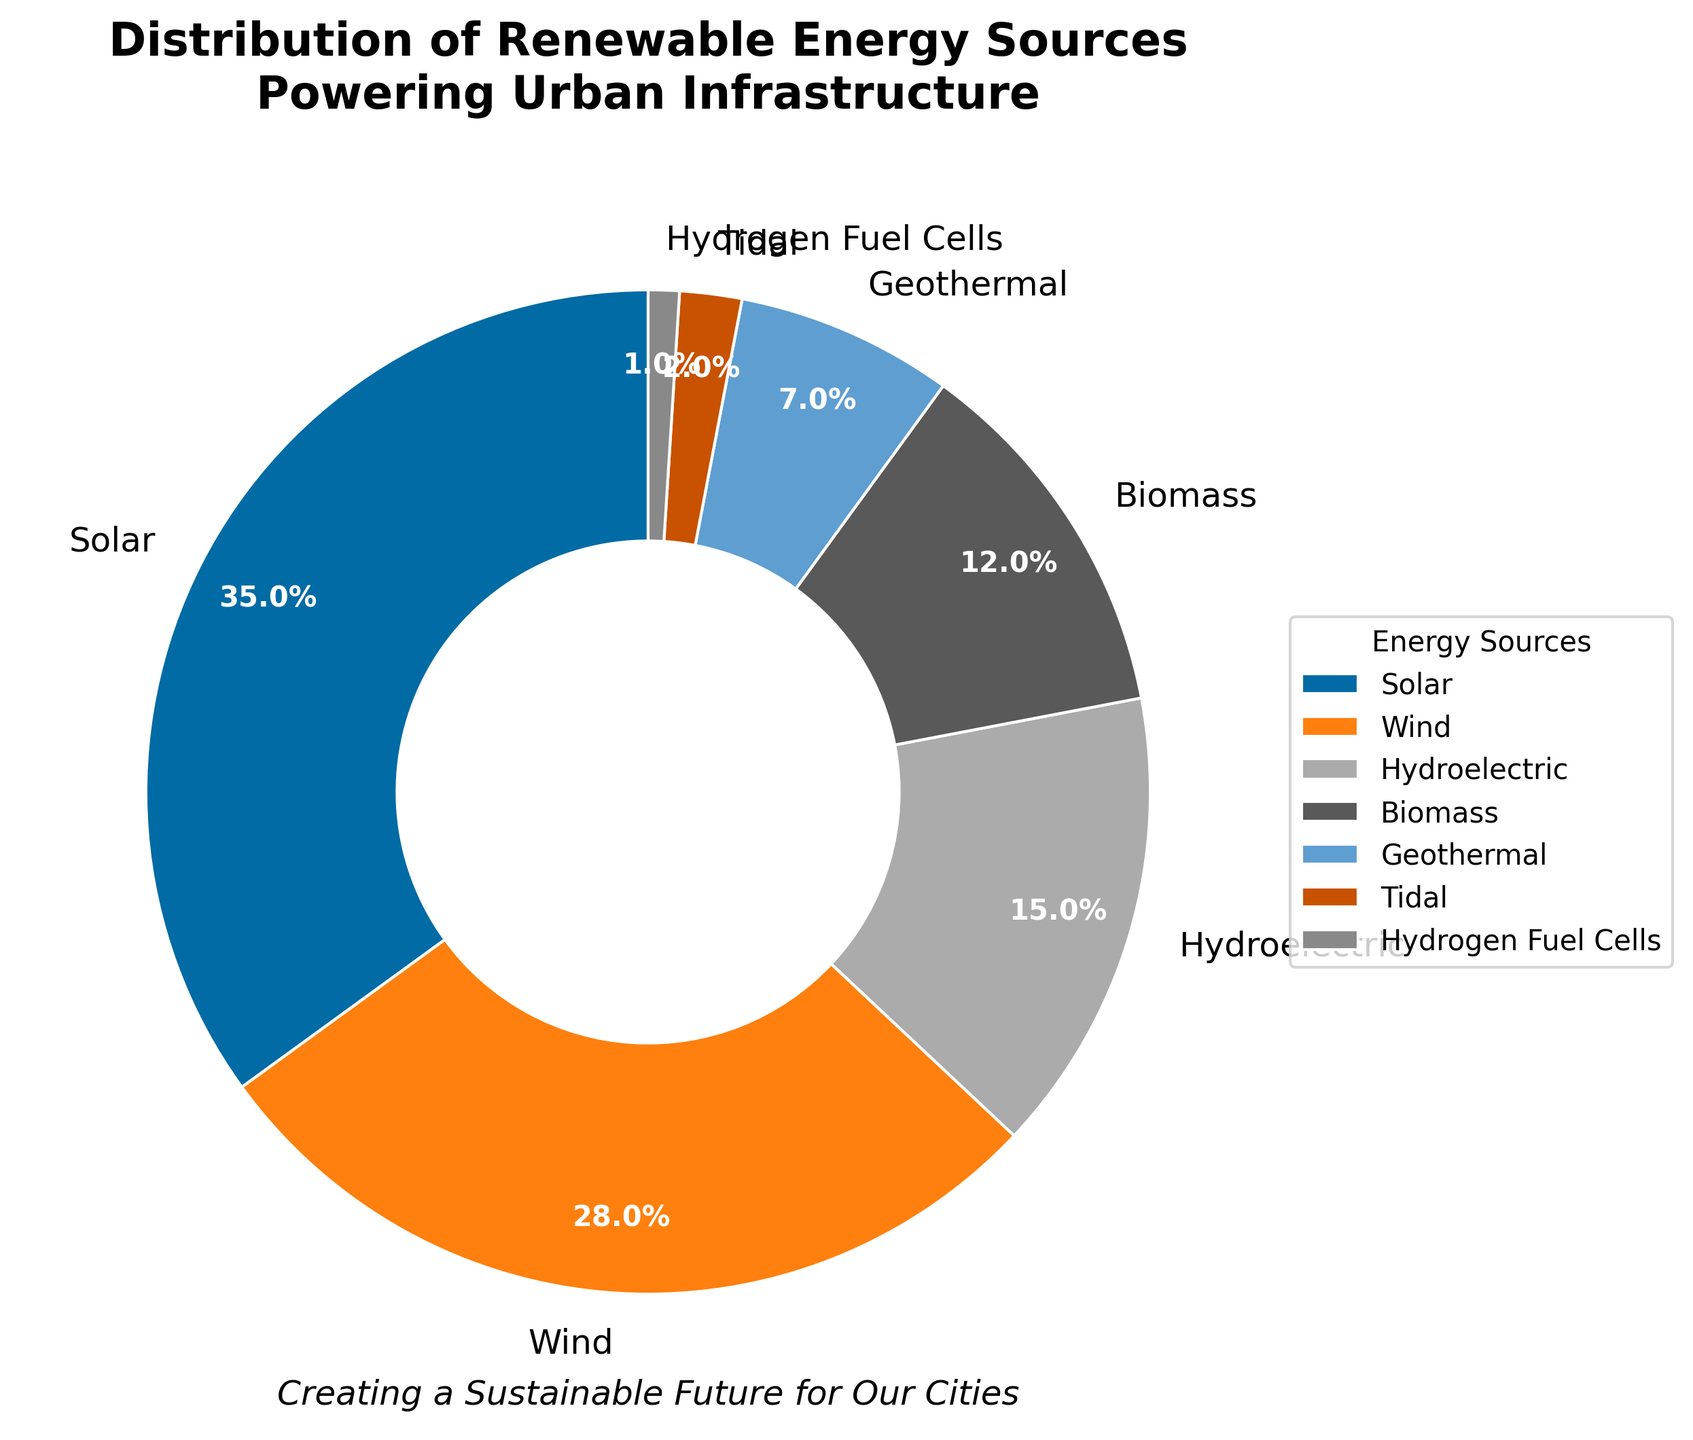What's the most used renewable energy source powering urban infrastructure? By looking at the pie chart, the segment labeled with the highest percentage represents the most used energy source. The largest segment is labeled "Solar" with 35%.
Answer: Solar Which renewable energy source has the smallest share? The smallest segment in the pie chart represents the least used energy source. The segment labeled "Hydrogen Fuel Cells" with 1% is the smallest.
Answer: Hydrogen Fuel Cells What is the combined percentage of Biomass and Geothermal energy sources? To find the combined percentage, sum the percentages of Biomass and Geothermal. Biomass is 12% and Geothermal is 7%, thus 12% + 7% = 19%.
Answer: 19% Which energy source contributes more, Wind or Hydroelectric? Compare the percentages of Wind and Hydroelectric on the pie chart. Wind contributes 28%, and Hydroelectric contributes 15%. Since 28% is greater than 15%, Wind contributes more.
Answer: Wind How much greater is the percentage of Solar compared to Tidal? Subtract the percentage of Tidal from the percentage of Solar. Solar is 35%, and Tidal is 2%, so 35% - 2% = 33%.
Answer: 33% What is the difference in percentage between Wind and Biomass? Subtract the percentage of Biomass from the percentage of Wind. Wind is 28%, and Biomass is 12%, so 28% - 12% = 16%.
Answer: 16% What percentage of renewable energy sources other than Solar power urban infrastructure? Subtract the percentage of Solar from 100% to find the combined percentage of all other sources. 100% - 35% = 65%.
Answer: 65% Which energy source is more prevalent, Geothermal or Tidal? Compare the percentages of Geothermal and Tidal. Geothermal is 7%, and Tidal is 2%. Since 7% is greater than 2%, Geothermal is more prevalent.
Answer: Geothermal Rank the renewable energy sources from most used to least used. Order the energy sources based on their percentages from highest to lowest: Solar (35%), Wind (28%), Hydroelectric (15%), Biomass (12%), Geothermal (7%), Tidal (2%), Hydrogen Fuel Cells (1%).
Answer: Solar, Wind, Hydroelectric, Biomass, Geothermal, Tidal, Hydrogen Fuel Cells What percentage of renewable energy sources is contributed by Wind, Hydroelectric, and Biomass combined? Sum the percentages of Wind, Hydroelectric, and Biomass. Wind is 28%, Hydroelectric is 15%, and Biomass is 12%, so 28% + 15% + 12% = 55%.
Answer: 55% 